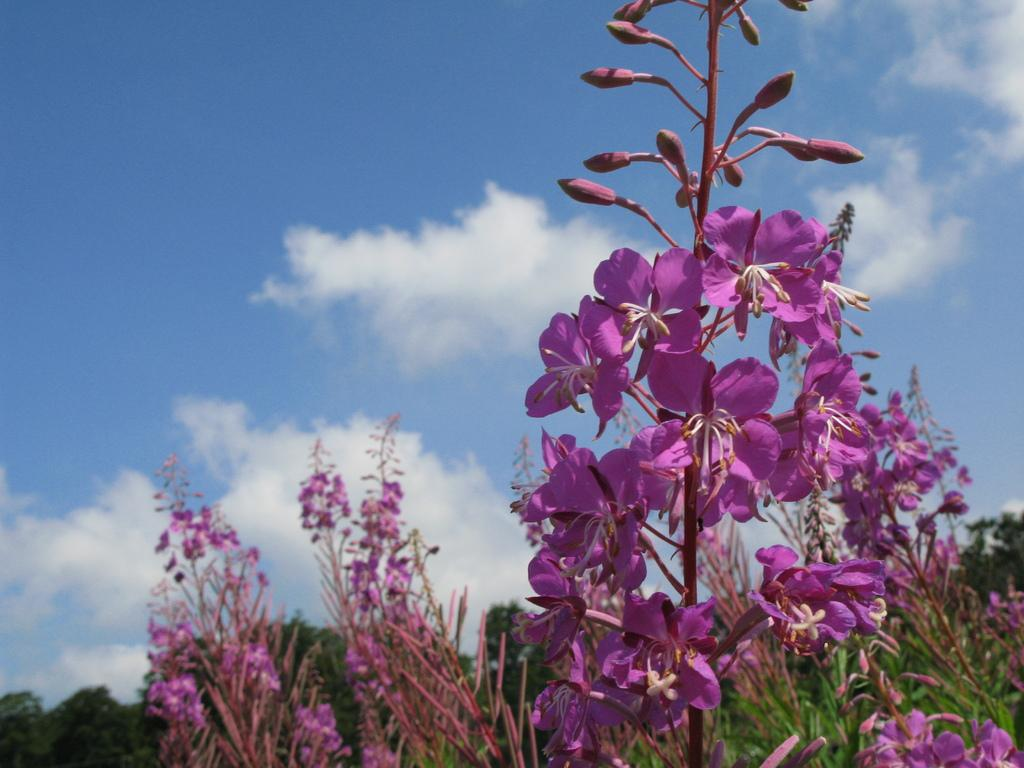What is the main subject of the image? The main subject of the image is plants and flowers. What color are the plants and flowers in the image? The plants and flowers are in pink color. What can be seen in the background of the image? In the background of the image, there is a sky, clouds, and trees. Where is the swing located in the image? There is no swing present in the image. What type of leaf is visible on the plants in the image? The provided facts do not mention any specific type of leaf on the plants in the image. 